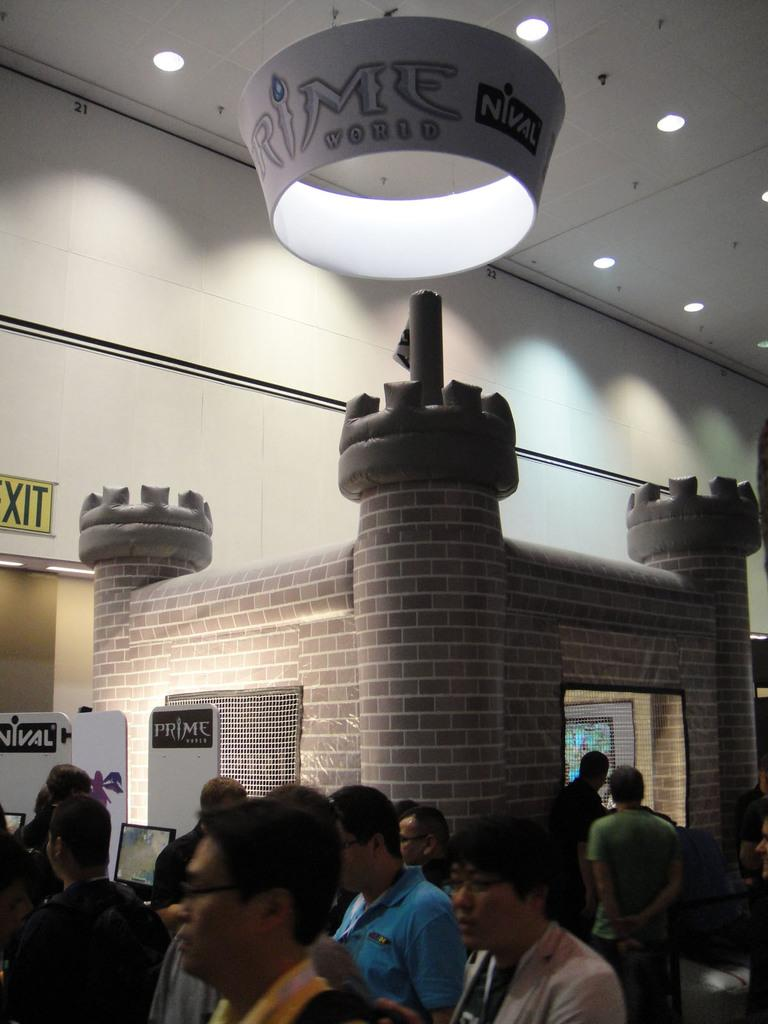What is happening in the room in the image? There are persons standing in a room in the image. What can be seen in the background of the image? There is a fort shape in the background of the image. What is visible at the top of the image? There are lights visible at the top of the image. What is covering the room in the image? There is a roof visible in the image. What type of rice is being cooked in the cellar in the image? There is no cellar or rice present in the image. What does the room need to make it more functional? The image does not suggest any specific needs for the room. 